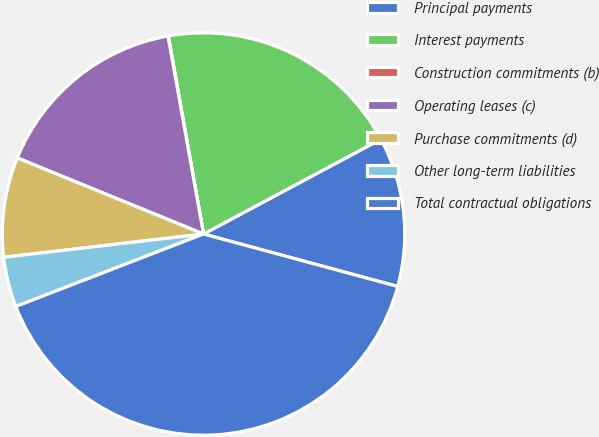Convert chart to OTSL. <chart><loc_0><loc_0><loc_500><loc_500><pie_chart><fcel>Principal payments<fcel>Interest payments<fcel>Construction commitments (b)<fcel>Operating leases (c)<fcel>Purchase commitments (d)<fcel>Other long-term liabilities<fcel>Total contractual obligations<nl><fcel>12.01%<fcel>19.99%<fcel>0.03%<fcel>16.0%<fcel>8.02%<fcel>4.02%<fcel>39.94%<nl></chart> 